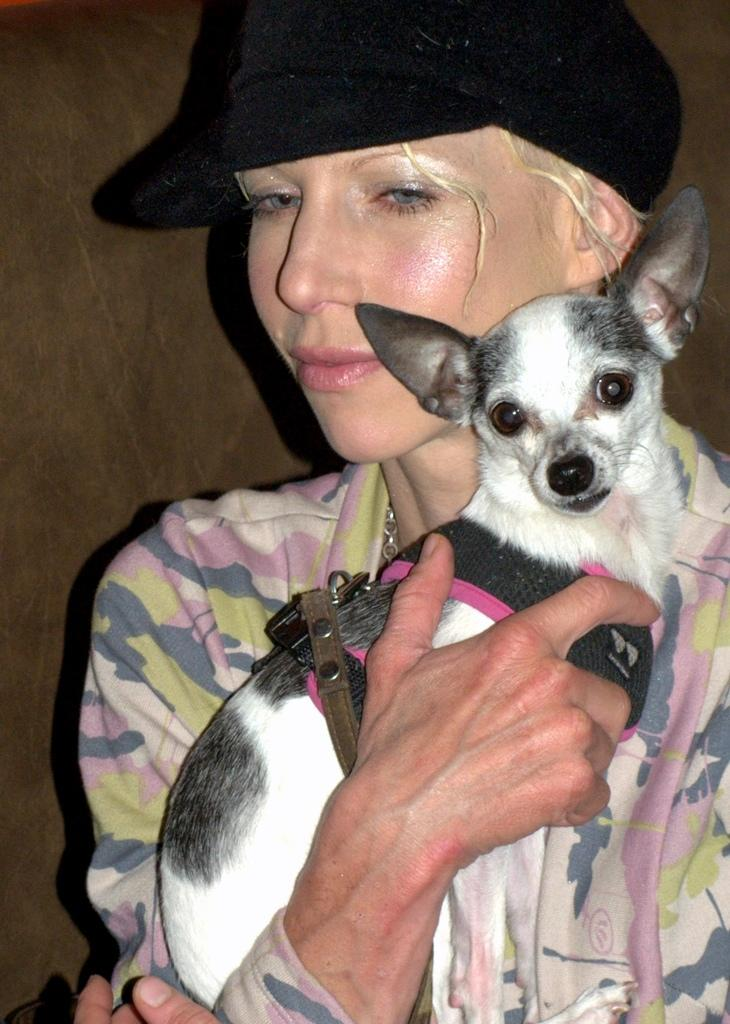Who is present in the image? There is a woman in the image. What is the woman doing in the image? The woman is standing near a wall. Is there any interaction between the woman and an animal in the image? Yes, the woman is holding a dog. What type of berry is the woman attempting to pick from the wall in the image? There is no berry present in the image, nor is the woman attempting to pick anything from the wall. 